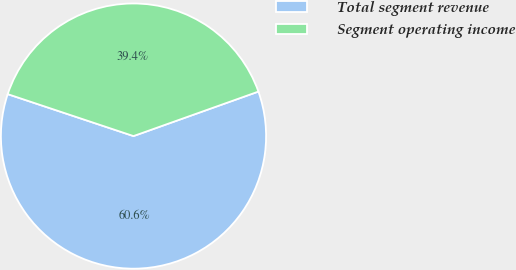Convert chart to OTSL. <chart><loc_0><loc_0><loc_500><loc_500><pie_chart><fcel>Total segment revenue<fcel>Segment operating income<nl><fcel>60.57%<fcel>39.43%<nl></chart> 